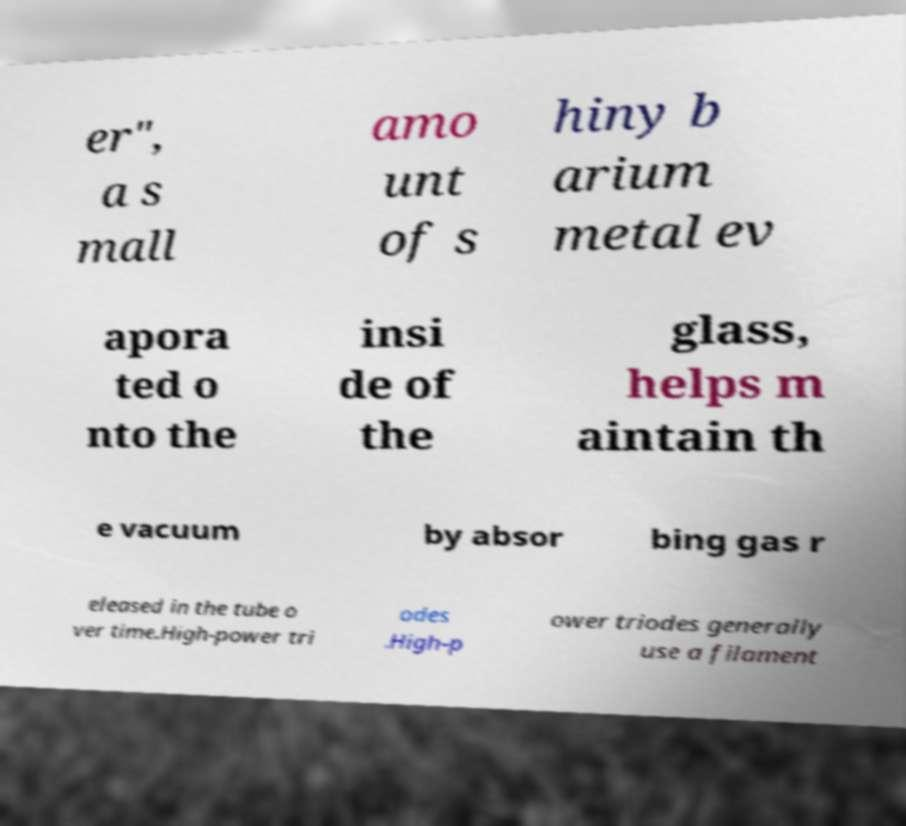I need the written content from this picture converted into text. Can you do that? er", a s mall amo unt of s hiny b arium metal ev apora ted o nto the insi de of the glass, helps m aintain th e vacuum by absor bing gas r eleased in the tube o ver time.High-power tri odes .High-p ower triodes generally use a filament 